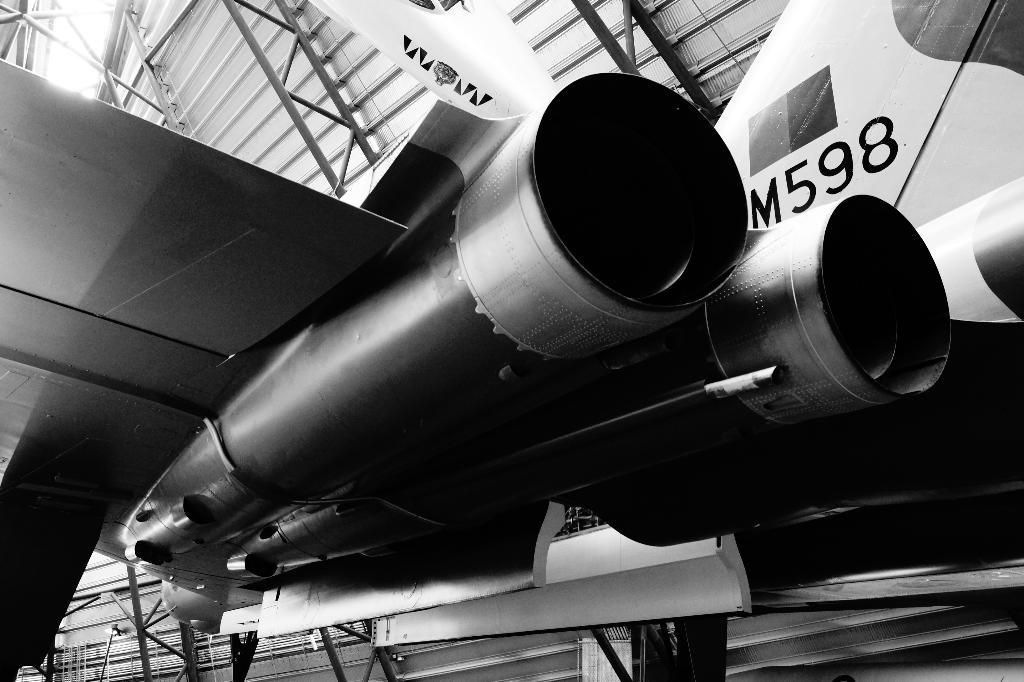What is the main subject of the image? The main subject of the image is an aircraft. Are there any markings or text on the aircraft? Yes, something is written on the aircraft. What is the color scheme of the image? The image is black and white in color. How many snails can be seen playing chess in the image? There are no snails or chess games present in the image; it features an aircraft with writing on it in black and white. 